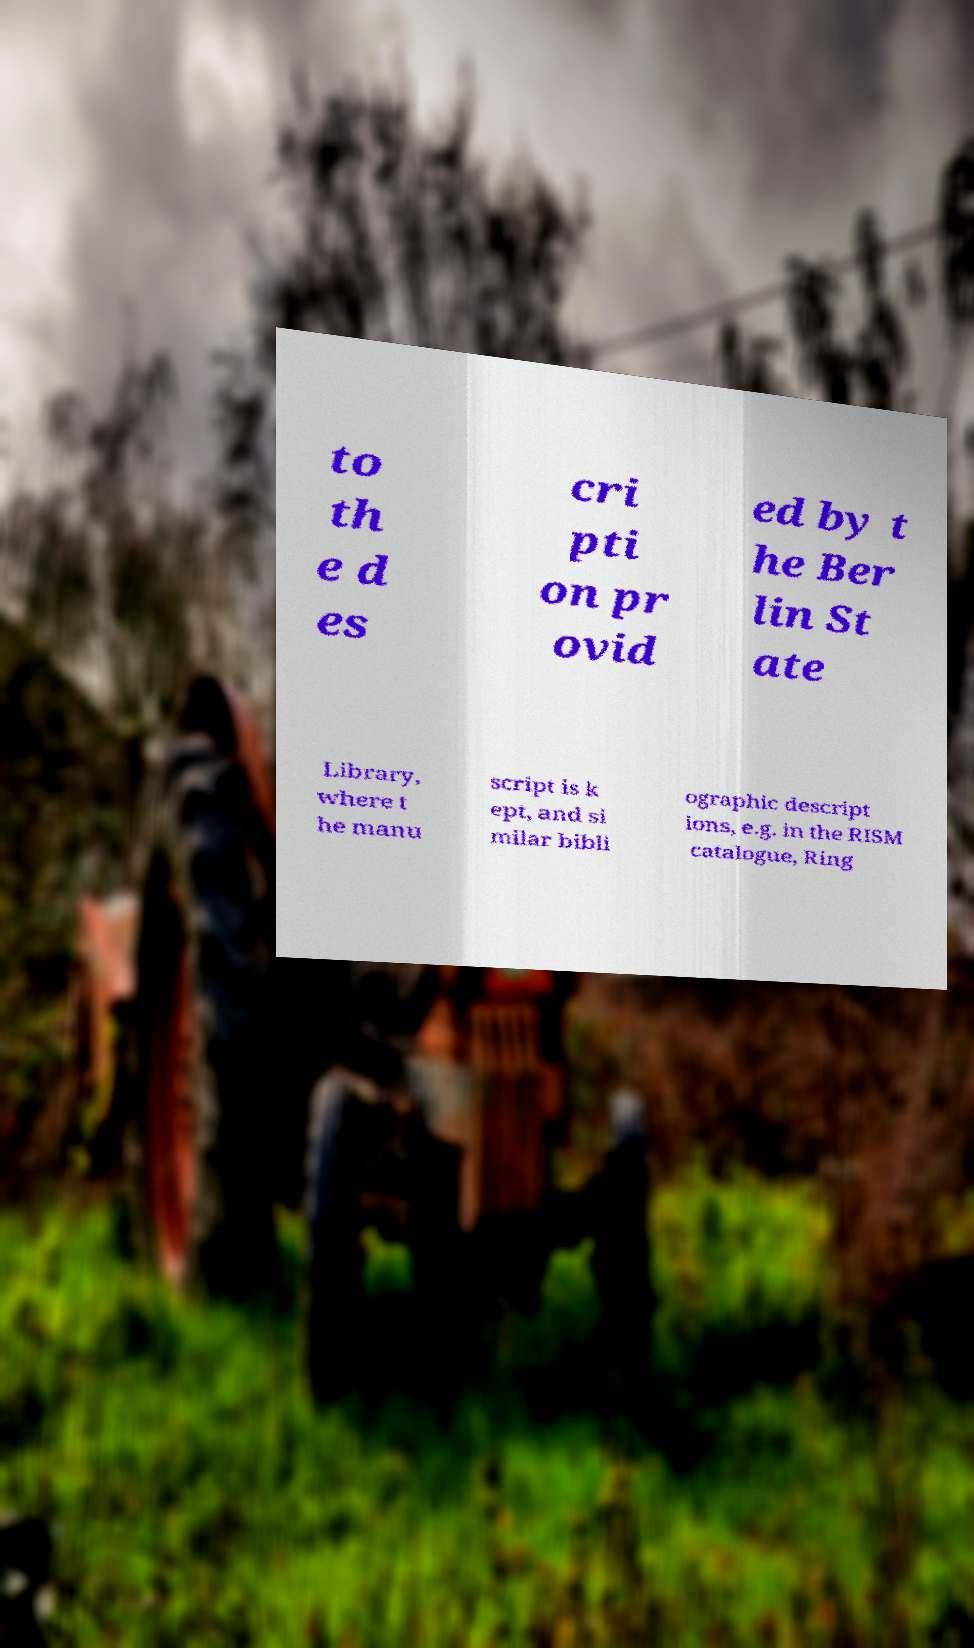Please identify and transcribe the text found in this image. to th e d es cri pti on pr ovid ed by t he Ber lin St ate Library, where t he manu script is k ept, and si milar bibli ographic descript ions, e.g. in the RISM catalogue, Ring 